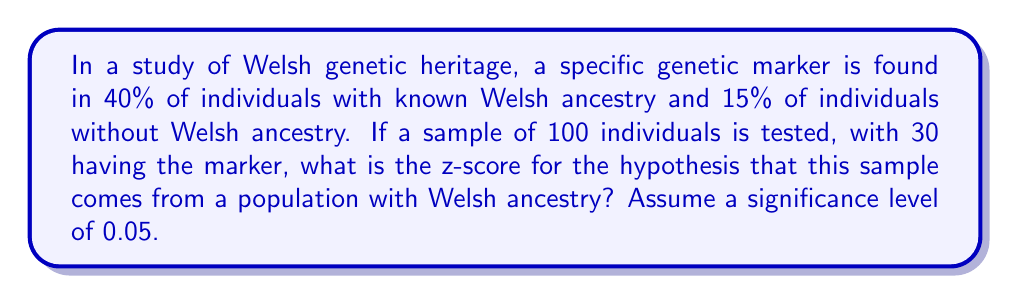What is the answer to this math problem? To solve this problem, we'll follow these steps:

1. Identify the null and alternative hypotheses:
   $H_0: p = 0.40$ (population has Welsh ancestry)
   $H_a: p \neq 0.40$ (population does not have Welsh ancestry)

2. Calculate the sample proportion:
   $\hat{p} = \frac{30}{100} = 0.30$

3. Calculate the standard error under the null hypothesis:
   $SE = \sqrt{\frac{p_0(1-p_0)}{n}} = \sqrt{\frac{0.40(1-0.40)}{100}} = 0.0490$

4. Calculate the z-score:
   $$z = \frac{\hat{p} - p_0}{SE} = \frac{0.30 - 0.40}{0.0490} = -2.0408$$

5. Interpret the result:
   At a significance level of 0.05, the critical z-values are ±1.96. Since our calculated z-score (-2.0408) falls outside this range, we would reject the null hypothesis.

This z-score indicates that the sample proportion is approximately 2.04 standard deviations below the hypothesized population proportion, suggesting that this sample is less likely to come from a population with Welsh ancestry.
Answer: $-2.0408$ 